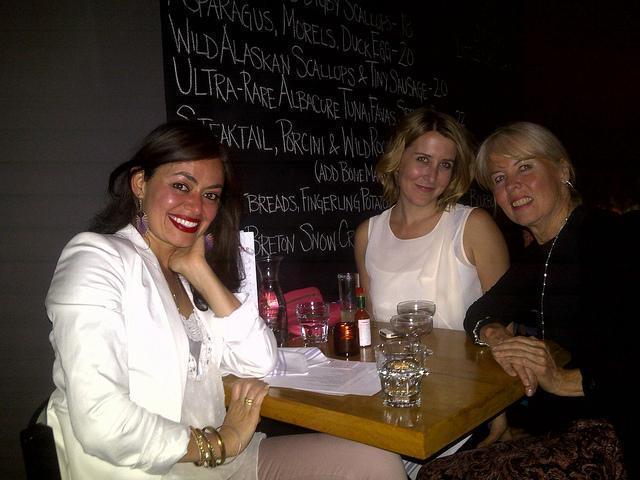What is this place?
Choose the correct response, then elucidate: 'Answer: answer
Rationale: rationale.'
Options: Seafood restaurant, photographer's studio, kitchen, bar. Answer: seafood restaurant.
Rationale: There are seafood items on the menu. 